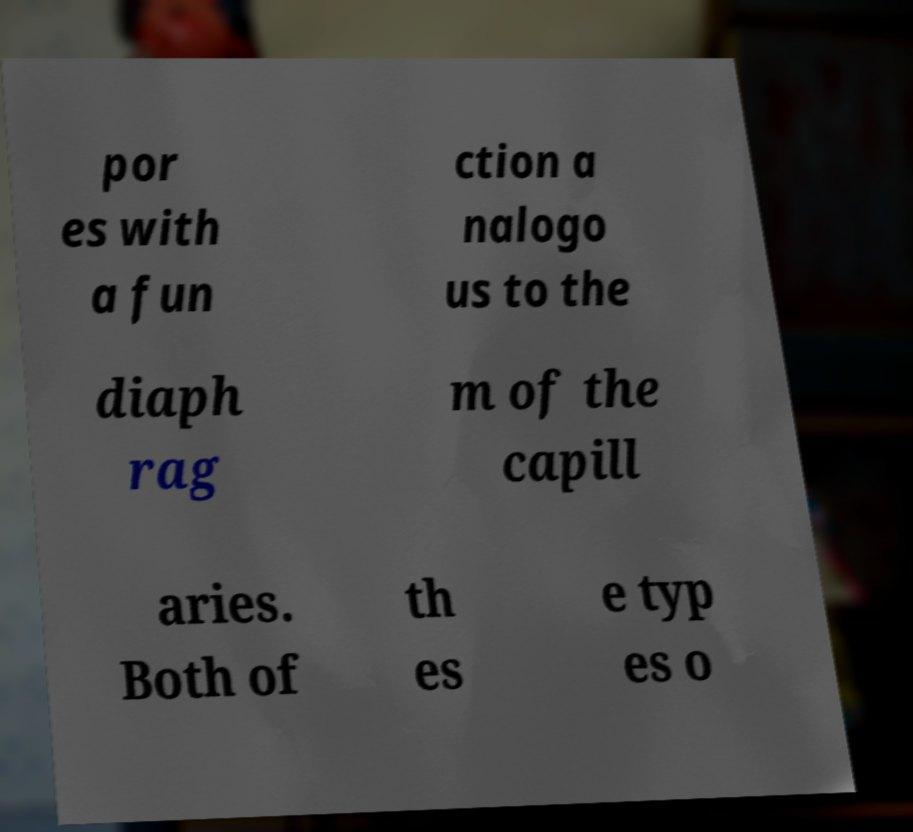For documentation purposes, I need the text within this image transcribed. Could you provide that? por es with a fun ction a nalogo us to the diaph rag m of the capill aries. Both of th es e typ es o 